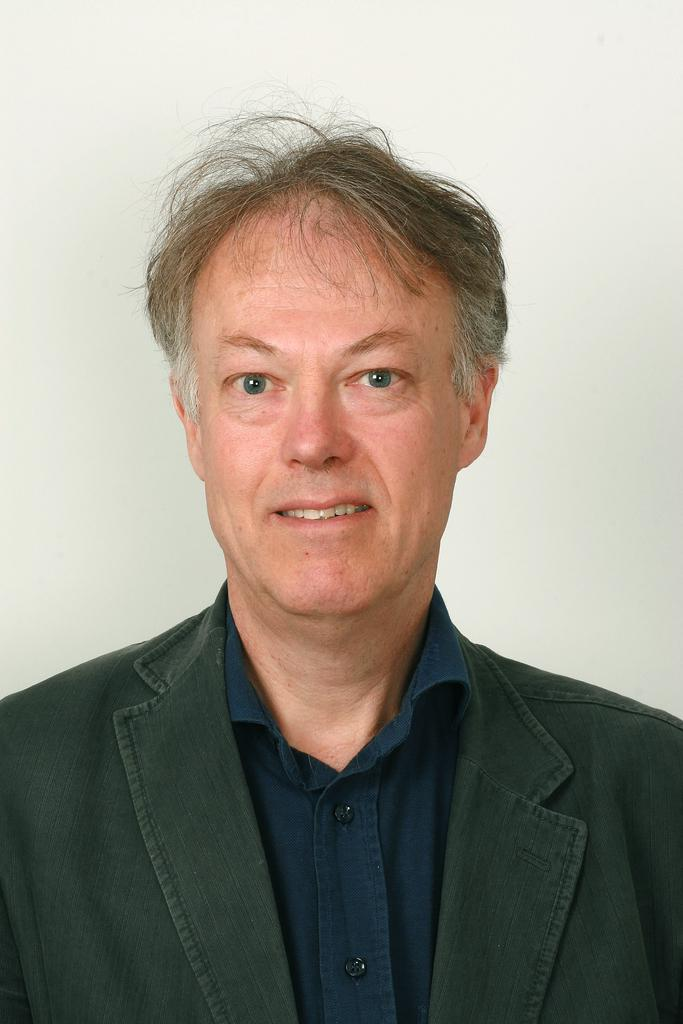Who is present in the image? There is a man in the image. What is the man wearing on his upper body? The man is wearing a shirt and a coat. What color is the background of the image? The background of the image is white. What type of blade can be seen in the man's hand in the image? There is no blade present in the man's hand or in the image. 